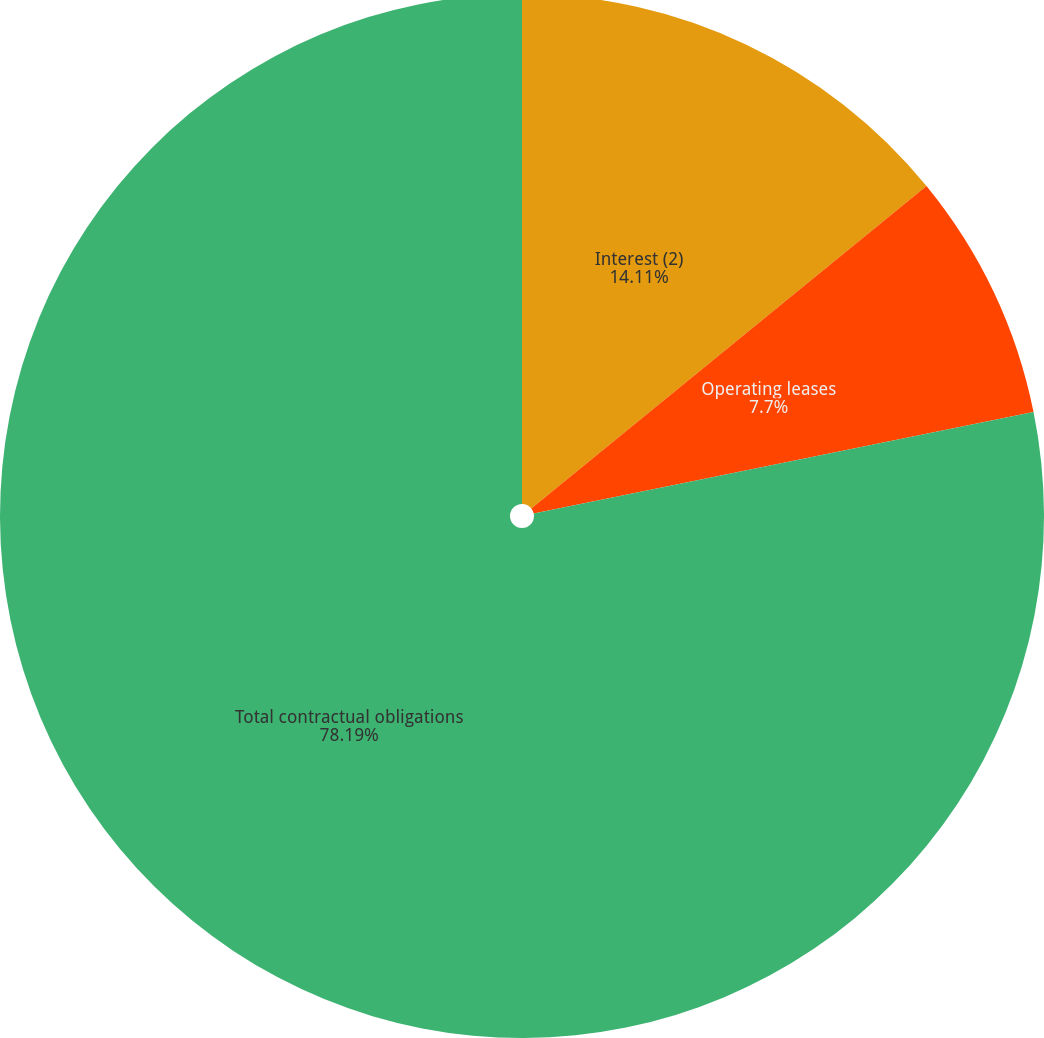<chart> <loc_0><loc_0><loc_500><loc_500><pie_chart><fcel>Interest (2)<fcel>Operating leases<fcel>Total contractual obligations<nl><fcel>14.11%<fcel>7.7%<fcel>78.19%<nl></chart> 